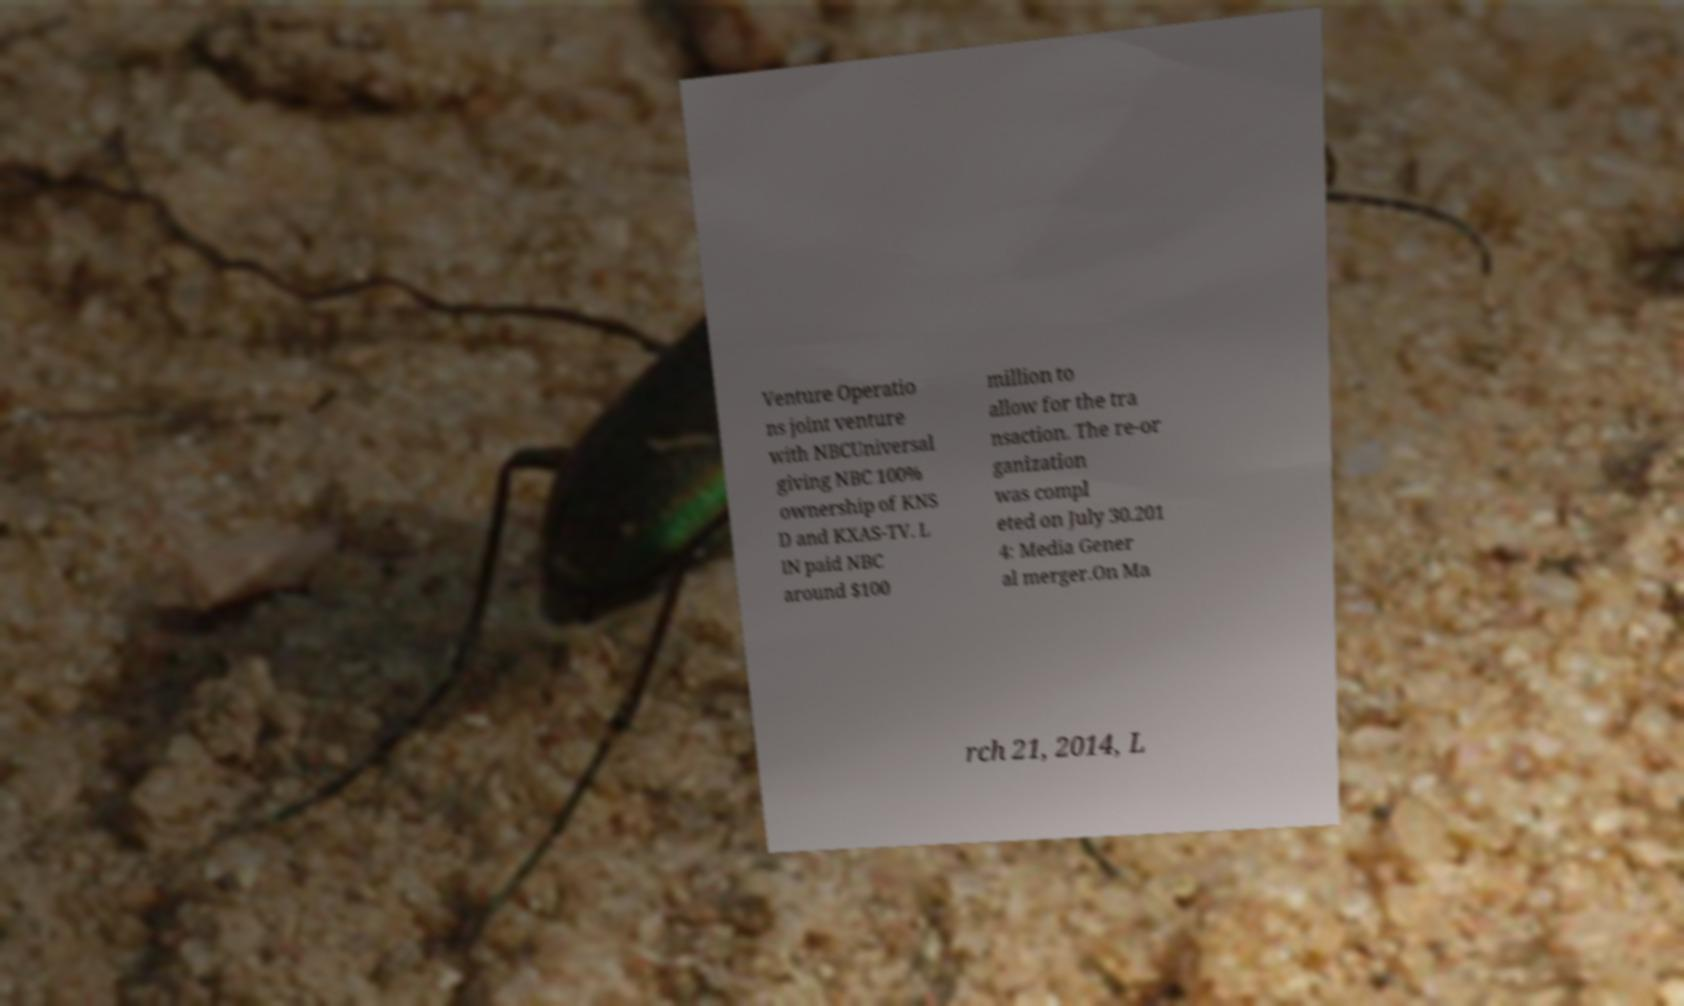Could you assist in decoding the text presented in this image and type it out clearly? Venture Operatio ns joint venture with NBCUniversal giving NBC 100% ownership of KNS D and KXAS-TV. L IN paid NBC around $100 million to allow for the tra nsaction. The re-or ganization was compl eted on July 30.201 4: Media Gener al merger.On Ma rch 21, 2014, L 